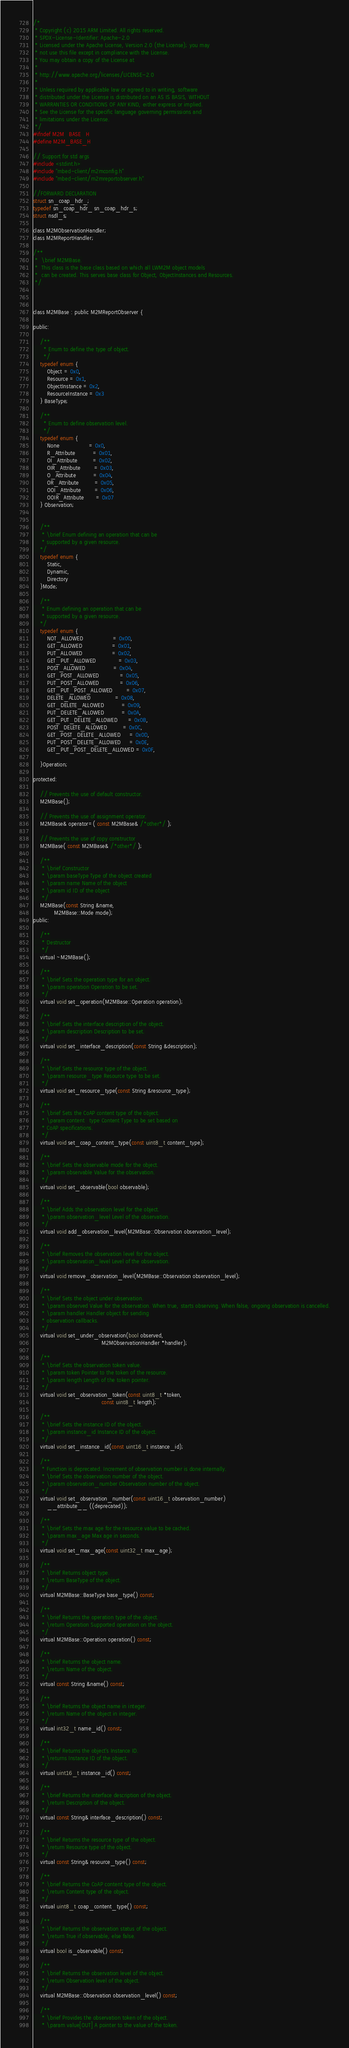<code> <loc_0><loc_0><loc_500><loc_500><_C_>/*
 * Copyright (c) 2015 ARM Limited. All rights reserved.
 * SPDX-License-Identifier: Apache-2.0
 * Licensed under the Apache License, Version 2.0 (the License); you may
 * not use this file except in compliance with the License.
 * You may obtain a copy of the License at
 *
 * http://www.apache.org/licenses/LICENSE-2.0
 *
 * Unless required by applicable law or agreed to in writing, software
 * distributed under the License is distributed on an AS IS BASIS, WITHOUT
 * WARRANTIES OR CONDITIONS OF ANY KIND, either express or implied.
 * See the License for the specific language governing permissions and
 * limitations under the License.
 */
#ifndef M2M_BASE_H
#define M2M_BASE_H

// Support for std args
#include <stdint.h>
#include "mbed-client/m2mconfig.h"
#include "mbed-client/m2mreportobserver.h"

//FORWARD DECLARATION
struct sn_coap_hdr_;
typedef sn_coap_hdr_ sn_coap_hdr_s;
struct nsdl_s;

class M2MObservationHandler;
class M2MReportHandler;

/**
 *  \brief M2MBase.
 *  This class is the base class based on which all LWM2M object models
 *  can be created. This serves base class for Object, ObjectInstances and Resources.
 */



class M2MBase : public M2MReportObserver {

public:

    /**
      * Enum to define the type of object.
      */
    typedef enum {
        Object = 0x0,
        Resource = 0x1,
        ObjectInstance = 0x2,
        ResourceInstance = 0x3
    } BaseType;

    /**
      * Enum to define observation level.
      */
    typedef enum {
        None                 = 0x0,
        R_Attribute          = 0x01,
        OI_Attribute         = 0x02,
        OIR_Attribute        = 0x03,
        O_Attribute          = 0x04,
        OR_Attribute         = 0x05,
        OOI_Attribute        = 0x06,
        OOIR_Attribute       = 0x07
    } Observation;


    /**
     * \brief Enum defining an operation that can be
     * supported by a given resource.
    */
    typedef enum {
        Static,
        Dynamic,
        Directory
    }Mode;

    /**
     * Enum defining an operation that can be
     * supported by a given resource.
    */
    typedef enum {
        NOT_ALLOWED                 = 0x00,
        GET_ALLOWED                 = 0x01,
        PUT_ALLOWED                 = 0x02,
        GET_PUT_ALLOWED             = 0x03,
        POST_ALLOWED                = 0x04,
        GET_POST_ALLOWED            = 0x05,
        PUT_POST_ALLOWED            = 0x06,
        GET_PUT_POST_ALLOWED        = 0x07,
        DELETE_ALLOWED              = 0x08,
        GET_DELETE_ALLOWED          = 0x09,
        PUT_DELETE_ALLOWED          = 0x0A,
        GET_PUT_DELETE_ALLOWED      = 0x0B,
        POST_DELETE_ALLOWED         = 0x0C,
        GET_POST_DELETE_ALLOWED     = 0x0D,
        PUT_POST_DELETE_ALLOWED     = 0x0E,
        GET_PUT_POST_DELETE_ALLOWED = 0x0F,

    }Operation;

protected:

    // Prevents the use of default constructor.
    M2MBase();

    // Prevents the use of assignment operator.
    M2MBase& operator=( const M2MBase& /*other*/ );

    // Prevents the use of copy constructor
    M2MBase( const M2MBase& /*other*/ );

    /**
     * \brief Constructor
     * \param baseType Type of the object created
     * \param name Name of the object
     * \param id ID of the object
     */
    M2MBase(const String &name,
            M2MBase::Mode mode);
public:

    /**
     * Destructor
     */
    virtual ~M2MBase();

    /**
     * \brief Sets the operation type for an object.
     * \param operation Operation to be set.
     */
    virtual void set_operation(M2MBase::Operation operation);

    /**
     * \brief Sets the interface description of the object.
     * \param description Description to be set.
     */
    virtual void set_interface_description(const String &description);

    /**
     * \brief Sets the resource type of the object.
     * \param resource_type Resource type to be set.
     */
    virtual void set_resource_type(const String &resource_type);

    /**
     * \brief Sets the CoAP content type of the object.
     * \param content_type Content Type to be set based on
     * CoAP specifications.
     */
    virtual void set_coap_content_type(const uint8_t content_type);

    /**
     * \brief Sets the observable mode for the object.
     * \param observable Value for the observation.
     */
    virtual void set_observable(bool observable);

    /**
     * \brief Adds the observation level for the object.
     * \param observation_level Level of the observation.
     */
    virtual void add_observation_level(M2MBase::Observation observation_level);

    /**
     * \brief Removes the observation level for the object.
     * \param observation_level Level of the observation.
     */
    virtual void remove_observation_level(M2MBase::Observation observation_level);

    /**
     * \brief Sets the object under observation.
     * \param observed Value for the observation. When true, starts observing. When false, ongoing observation is cancelled.
     * \param handler Handler object for sending
     * observation callbacks.
     */
    virtual void set_under_observation(bool observed,
                                       M2MObservationHandler *handler);

    /**
     * \brief Sets the observation token value.
     * \param token Pointer to the token of the resource.
     * \param length Length of the token pointer.
     */
    virtual void set_observation_token(const uint8_t *token,
                                       const uint8_t length);

    /**
     * \brief Sets the instance ID of the object.
     * \param instance_id Instance ID of the object.
     */
    virtual void set_instance_id(const uint16_t instance_id);

    /**
     * Function is deprecated. Increment of observation number is done internally.
     * \brief Sets the observation number of the object.
     * \param observation_number Observation number of the object.
     */
    virtual void set_observation_number(const uint16_t observation_number)
        __attribute__ ((deprecated));

    /**
     * \brief Sets the max age for the resource value to be cached.
     * \param max_age Max age in seconds.
     */
    virtual void set_max_age(const uint32_t max_age);

    /**
     * \brief Returns object type.
     * \return BaseType of the object.
     */
    virtual M2MBase::BaseType base_type() const;

    /**
     * \brief Returns the operation type of the object.
     * \return Operation Supported operation on the object.
     */
    virtual M2MBase::Operation operation() const;

    /**
     * \brief Returns the object name.
     * \return Name of the object.
     */
    virtual const String &name() const;

    /**
     * \brief Returns the object name in integer.
     * \return Name of the object in integer.
     */
    virtual int32_t name_id() const;

    /**
     * \brief Returns the object's Instance ID.
     * \returns Instance ID of the object.
     */
    virtual uint16_t instance_id() const;

    /**
     * \brief Returns the interface description of the object.
     * \return Description of the object.
     */
    virtual const String& interface_description() const;

    /**
     * \brief Returns the resource type of the object.
     * \return Resource type of the object.
     */
    virtual const String& resource_type() const;

    /**
     * \brief Returns the CoAP content type of the object.
     * \return Content type of the object.
     */
    virtual uint8_t coap_content_type() const;

    /**
     * \brief Returns the observation status of the object.
     * \return True if observable, else false.
     */
    virtual bool is_observable() const;

    /**
     * \brief Returns the observation level of the object.
     * \return Observation level of the object.
     */
    virtual M2MBase::Observation observation_level() const;

    /**
     * \brief Provides the observation token of the object.
     * \param value[OUT] A pointer to the value of the token.</code> 